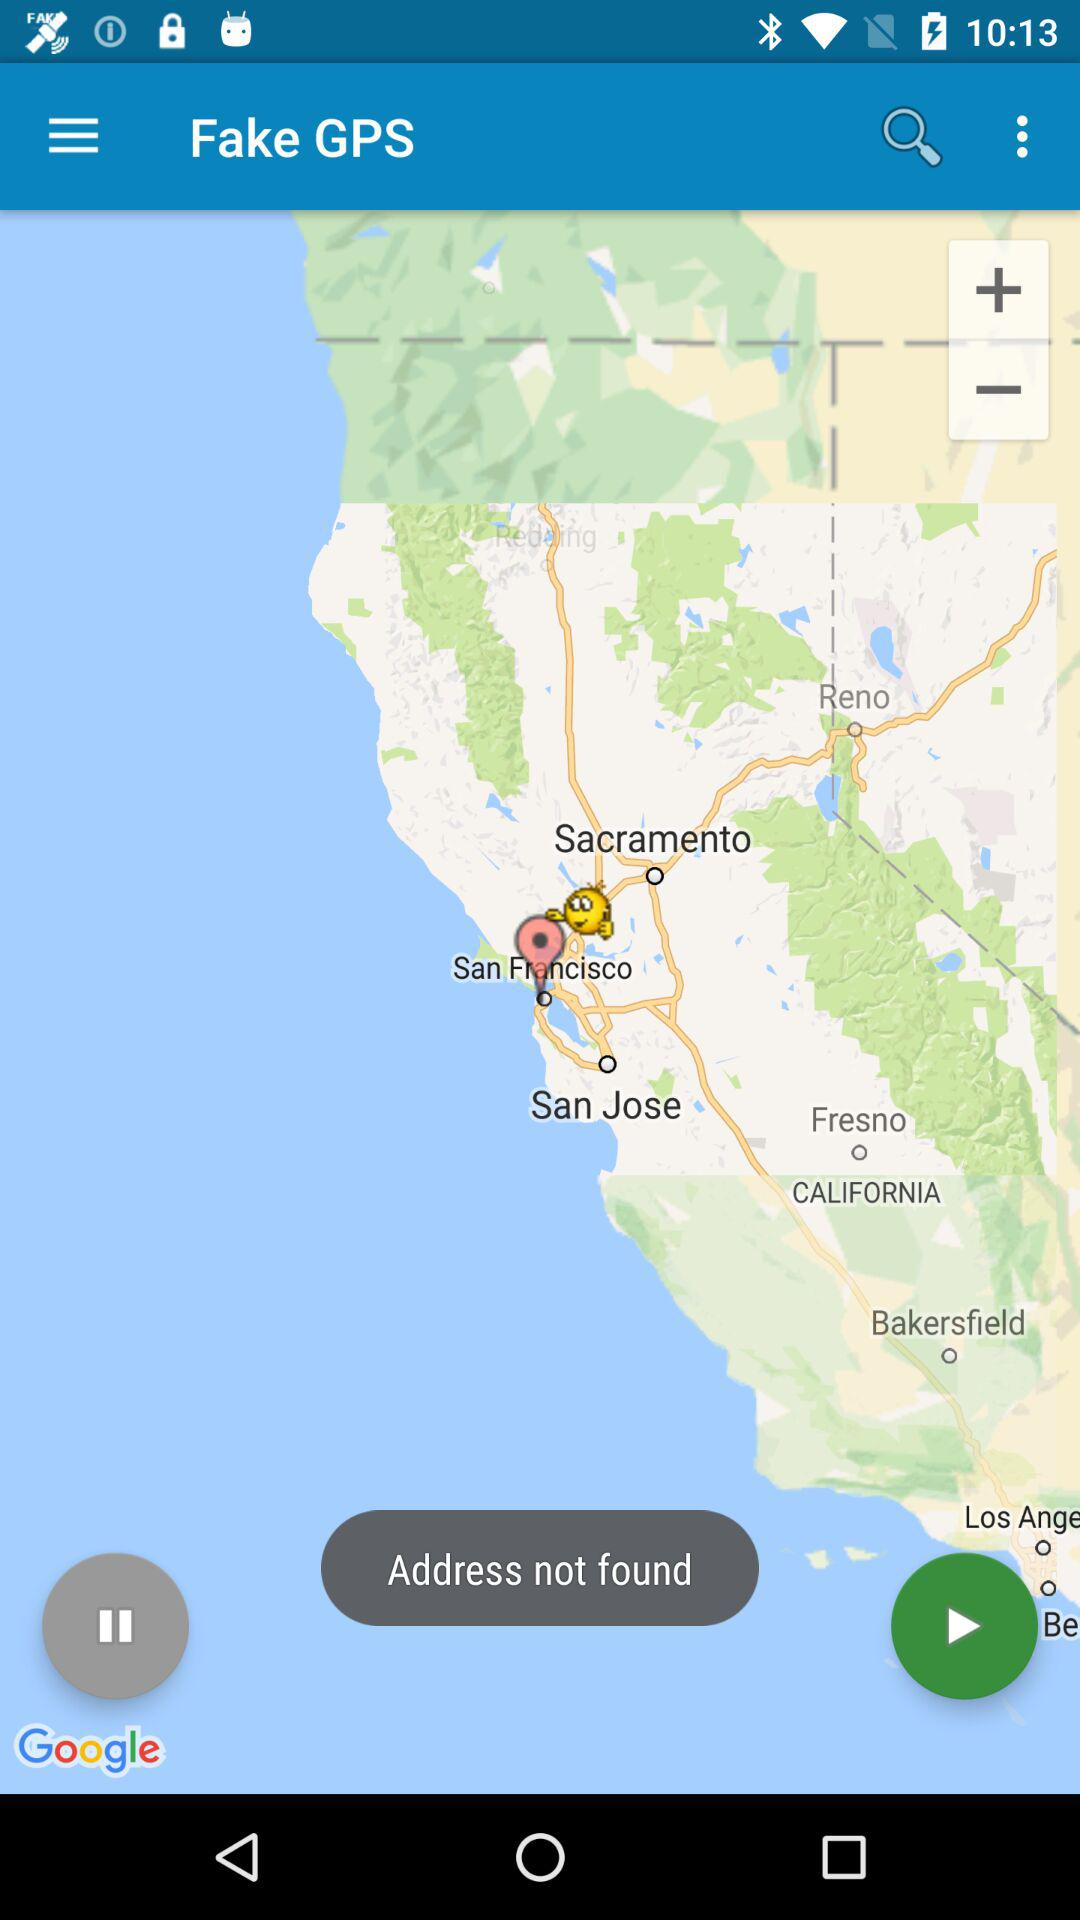What is the name of the application? The name of the application is "Fake GPS". 